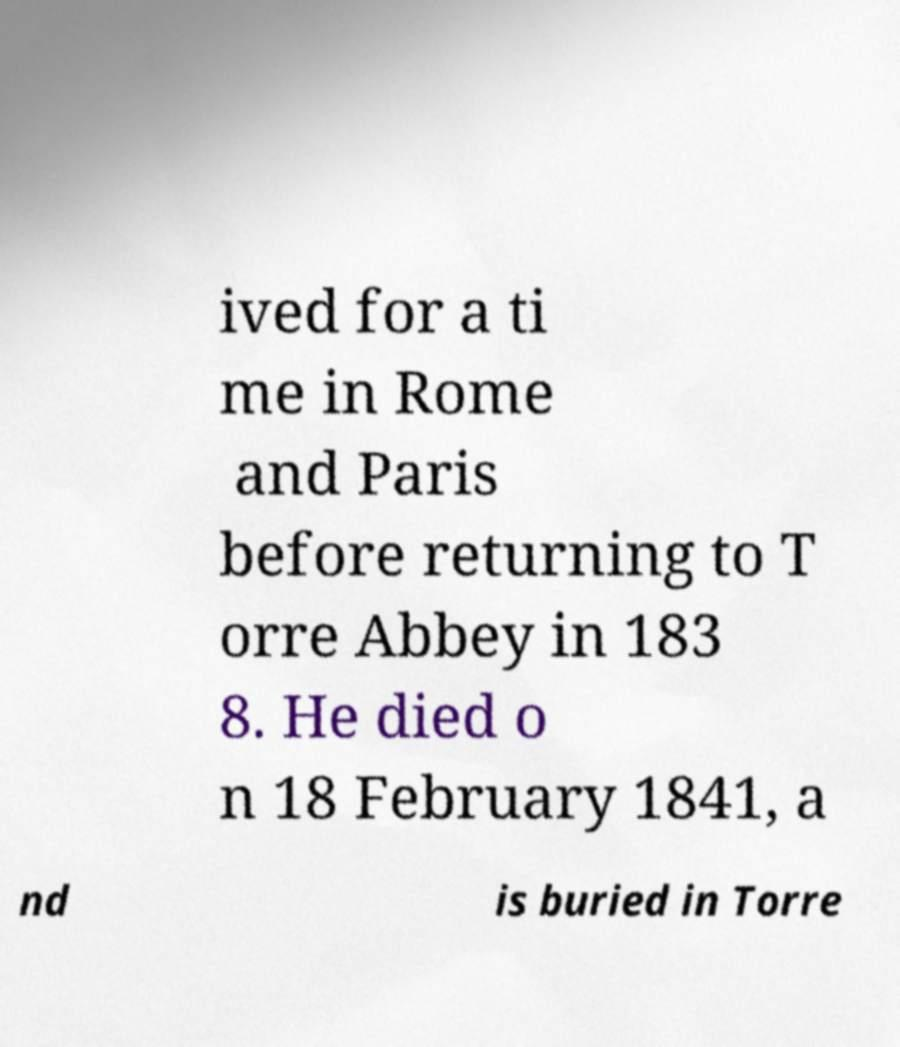Please identify and transcribe the text found in this image. ived for a ti me in Rome and Paris before returning to T orre Abbey in 183 8. He died o n 18 February 1841, a nd is buried in Torre 